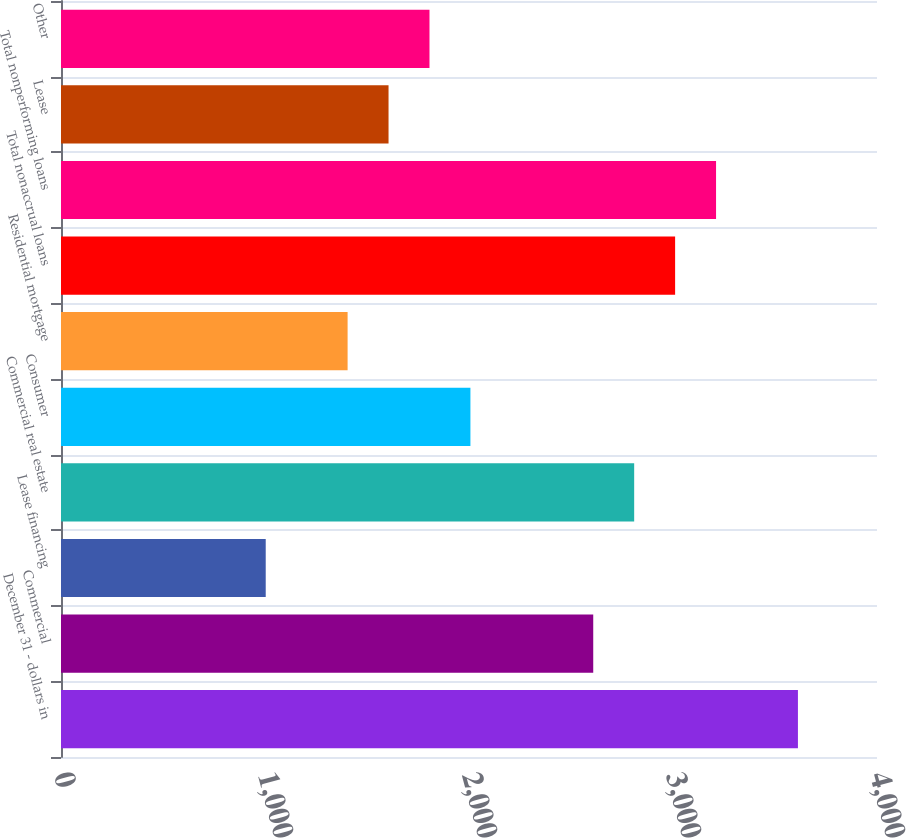Convert chart. <chart><loc_0><loc_0><loc_500><loc_500><bar_chart><fcel>December 31 - dollars in<fcel>Commercial<fcel>Lease financing<fcel>Commercial real estate<fcel>Consumer<fcel>Residential mortgage<fcel>Total nonaccrual loans<fcel>Total nonperforming loans<fcel>Lease<fcel>Other<nl><fcel>3612.4<fcel>2609<fcel>1003.56<fcel>2809.68<fcel>2006.96<fcel>1404.92<fcel>3010.36<fcel>3211.04<fcel>1605.6<fcel>1806.28<nl></chart> 